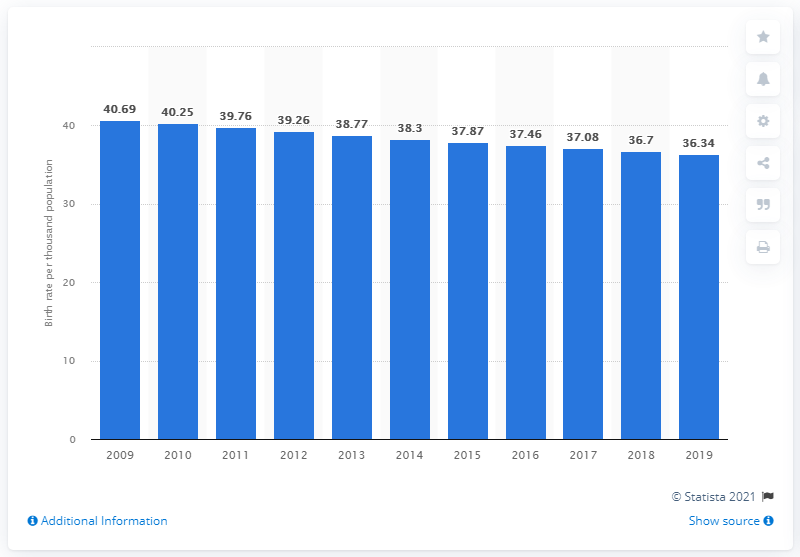List a handful of essential elements in this visual. The crude birth rate in Tanzania in 2019 was 36.34. 